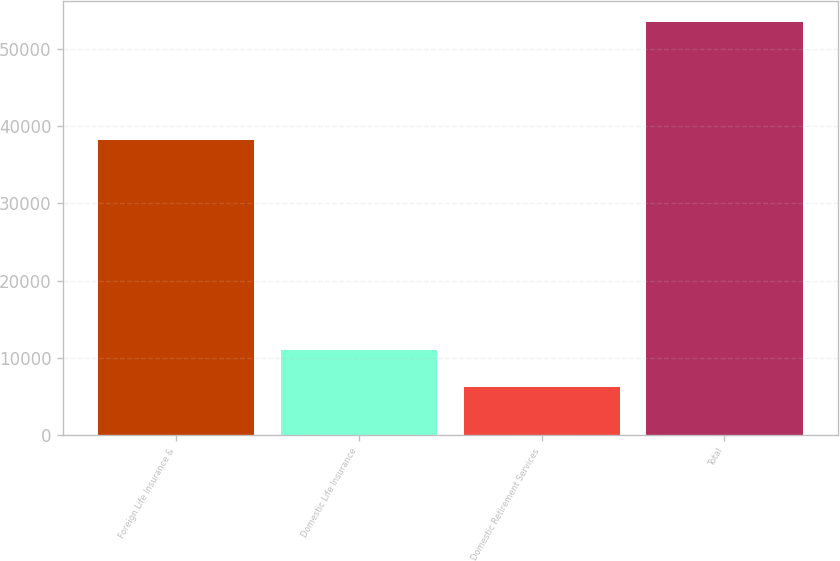Convert chart. <chart><loc_0><loc_0><loc_500><loc_500><bar_chart><fcel>Foreign Life Insurance &<fcel>Domestic Life Insurance<fcel>Domestic Retirement Services<fcel>Total<nl><fcel>38263<fcel>11008.1<fcel>6279<fcel>53570<nl></chart> 